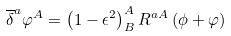<formula> <loc_0><loc_0><loc_500><loc_500>\overline { \delta } ^ { a } \varphi ^ { A } = \left ( 1 - \epsilon ^ { 2 } \right ) _ { B } ^ { A } R ^ { a A } \left ( \phi + \varphi \right )</formula> 